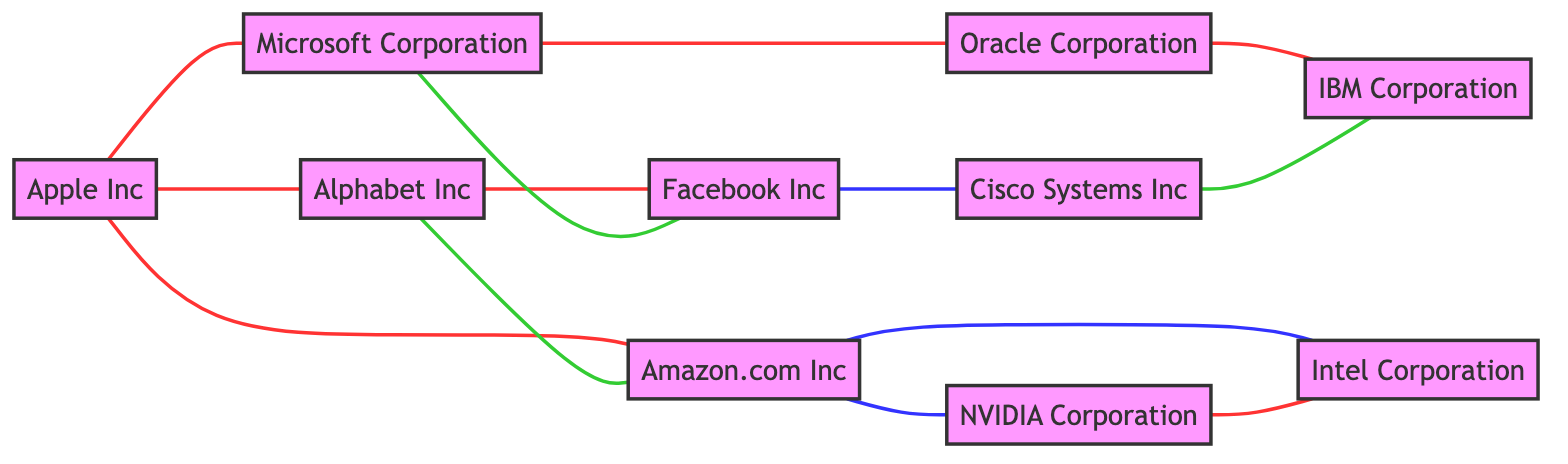What is the total number of companies represented in the diagram? There are 10 nodes, each of which represents a company. This can be counted from the "nodes" section of the input data.
Answer: 10 What is the relationship between Apple Inc and Microsoft Corporation? The edge connecting Apple Inc and Microsoft Corporation indicates a "Competition" relationship. This relationship is explicitly stated in the edges list.
Answer: Competition Which company has a partnership with Facebook Inc? The edge connecting Microsoft Corporation to Facebook Inc indicates a "Partnership" relationship, thus Microsoft Corporation is the answer.
Answer: Microsoft Corporation How many supplier relationships does Amazon.com Inc have? Amazon.com Inc has two supplier relationships: with Intel Corporation and NVIDIA Corporation. This can be counted from the relevant edges.
Answer: 2 Which companies compete with Oracle Corporation? The edge indicating competition links Oracle Corporation to Microsoft Corporation and IBM Corporation, making these the competitors.
Answer: Microsoft Corporation, IBM Corporation What is the total number of edges in the diagram? There are 12 edges connecting the various companies, which can be counted from the "edges" section of the input data.
Answer: 12 List the companies that are connected to Cisco Systems Inc. Cisco Systems Inc is connected to Facebook Inc (Supplier) and IBM Corporation (Partnership), which can be identified from the edges.
Answer: Facebook Inc, IBM Corporation Which company is in a competitive relationship with both Intel Corporation and NVIDIA Corporation? The relationship between NVIDIA Corporation and Intel Corporation, and their individual links to Amazon.com Inc (supplier) both indicate competition involves NVIDIA Corporation as it competes with both.
Answer: NVIDIA Corporation What type of relationship exists between Alphabet Inc and Amazon.com Inc? The edge indicates that Alphabet Inc has a "Partnership" with Amazon.com Inc, clearly noted in the relationships provided in the edges.
Answer: Partnership 